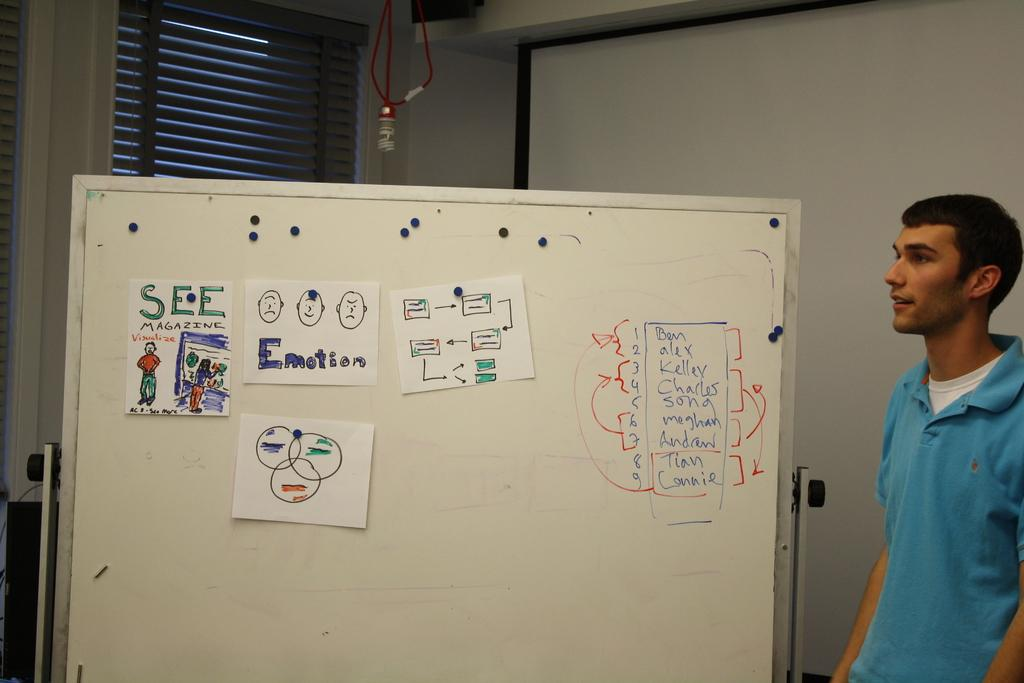<image>
Provide a brief description of the given image. Someone has drawn a picture of See Magazine and pasted it on the board. 